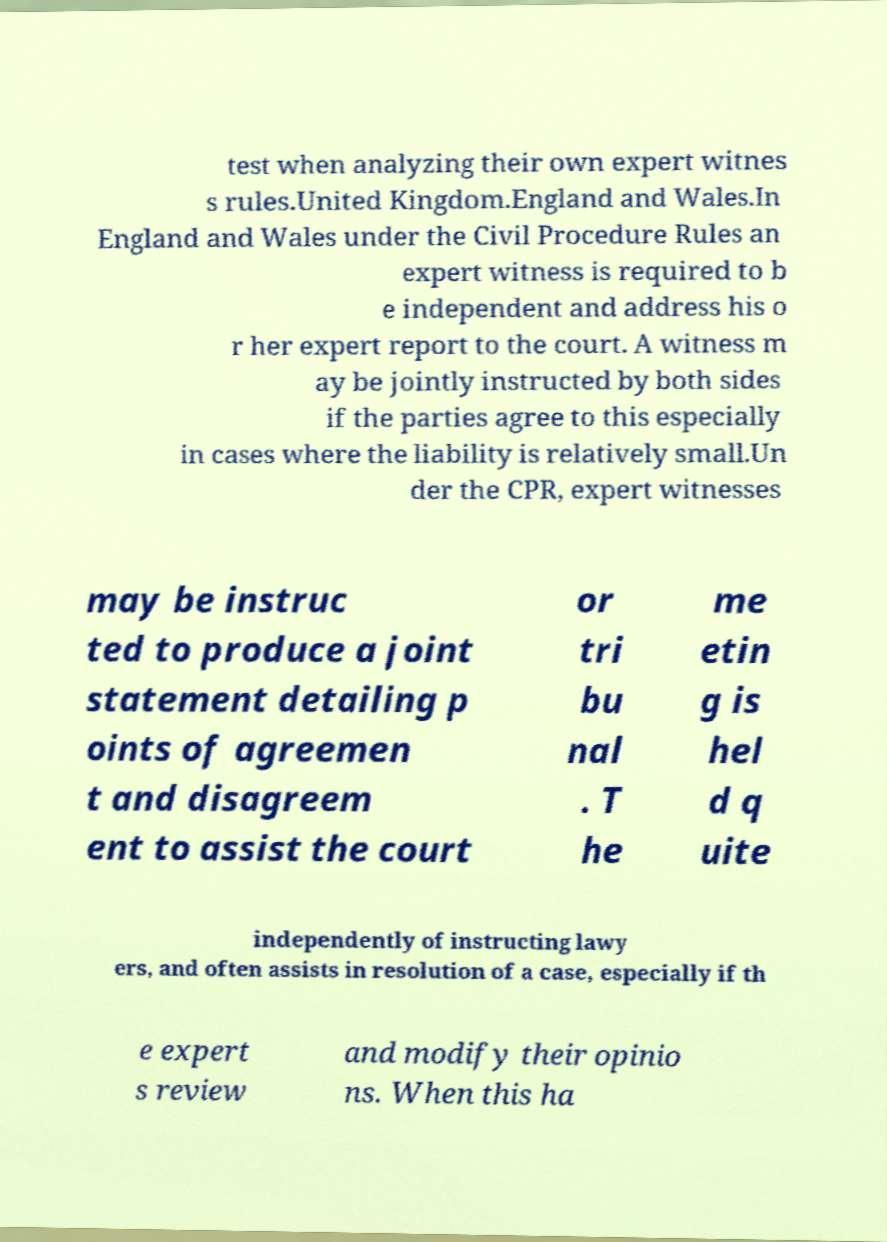What messages or text are displayed in this image? I need them in a readable, typed format. test when analyzing their own expert witnes s rules.United Kingdom.England and Wales.In England and Wales under the Civil Procedure Rules an expert witness is required to b e independent and address his o r her expert report to the court. A witness m ay be jointly instructed by both sides if the parties agree to this especially in cases where the liability is relatively small.Un der the CPR, expert witnesses may be instruc ted to produce a joint statement detailing p oints of agreemen t and disagreem ent to assist the court or tri bu nal . T he me etin g is hel d q uite independently of instructing lawy ers, and often assists in resolution of a case, especially if th e expert s review and modify their opinio ns. When this ha 